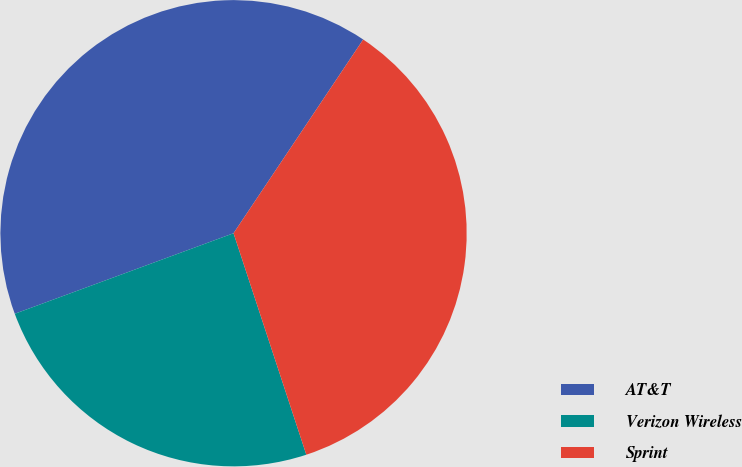Convert chart. <chart><loc_0><loc_0><loc_500><loc_500><pie_chart><fcel>AT&T<fcel>Verizon Wireless<fcel>Sprint<nl><fcel>40.0%<fcel>24.44%<fcel>35.56%<nl></chart> 